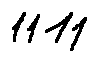Convert formula to latex. <formula><loc_0><loc_0><loc_500><loc_500>1 1 1 1</formula> 